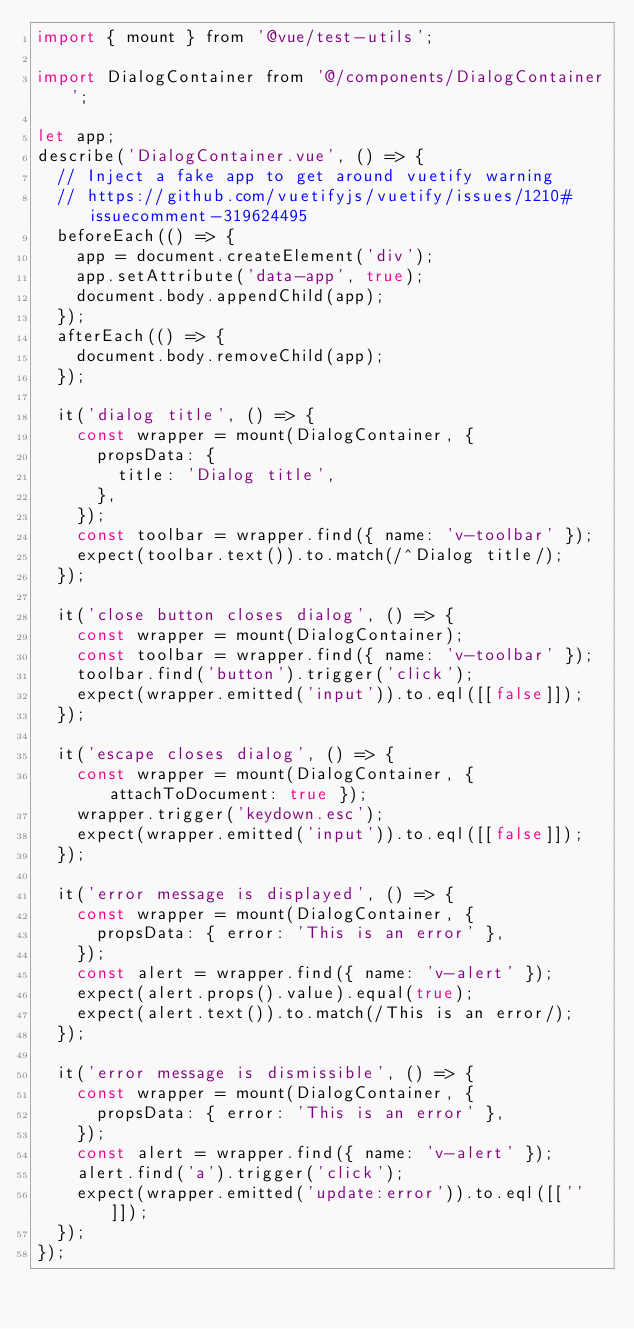Convert code to text. <code><loc_0><loc_0><loc_500><loc_500><_JavaScript_>import { mount } from '@vue/test-utils';

import DialogContainer from '@/components/DialogContainer';

let app;
describe('DialogContainer.vue', () => {
  // Inject a fake app to get around vuetify warning
  // https://github.com/vuetifyjs/vuetify/issues/1210#issuecomment-319624495
  beforeEach(() => {
    app = document.createElement('div');
    app.setAttribute('data-app', true);
    document.body.appendChild(app);
  });
  afterEach(() => {
    document.body.removeChild(app);
  });

  it('dialog title', () => {
    const wrapper = mount(DialogContainer, {
      propsData: {
        title: 'Dialog title',
      },
    });
    const toolbar = wrapper.find({ name: 'v-toolbar' });
    expect(toolbar.text()).to.match(/^Dialog title/);
  });

  it('close button closes dialog', () => {
    const wrapper = mount(DialogContainer);
    const toolbar = wrapper.find({ name: 'v-toolbar' });
    toolbar.find('button').trigger('click');
    expect(wrapper.emitted('input')).to.eql([[false]]);
  });

  it('escape closes dialog', () => {
    const wrapper = mount(DialogContainer, { attachToDocument: true });
    wrapper.trigger('keydown.esc');
    expect(wrapper.emitted('input')).to.eql([[false]]);
  });

  it('error message is displayed', () => {
    const wrapper = mount(DialogContainer, {
      propsData: { error: 'This is an error' },
    });
    const alert = wrapper.find({ name: 'v-alert' });
    expect(alert.props().value).equal(true);
    expect(alert.text()).to.match(/This is an error/);
  });

  it('error message is dismissible', () => {
    const wrapper = mount(DialogContainer, {
      propsData: { error: 'This is an error' },
    });
    const alert = wrapper.find({ name: 'v-alert' });
    alert.find('a').trigger('click');
    expect(wrapper.emitted('update:error')).to.eql([['']]);
  });
});
</code> 